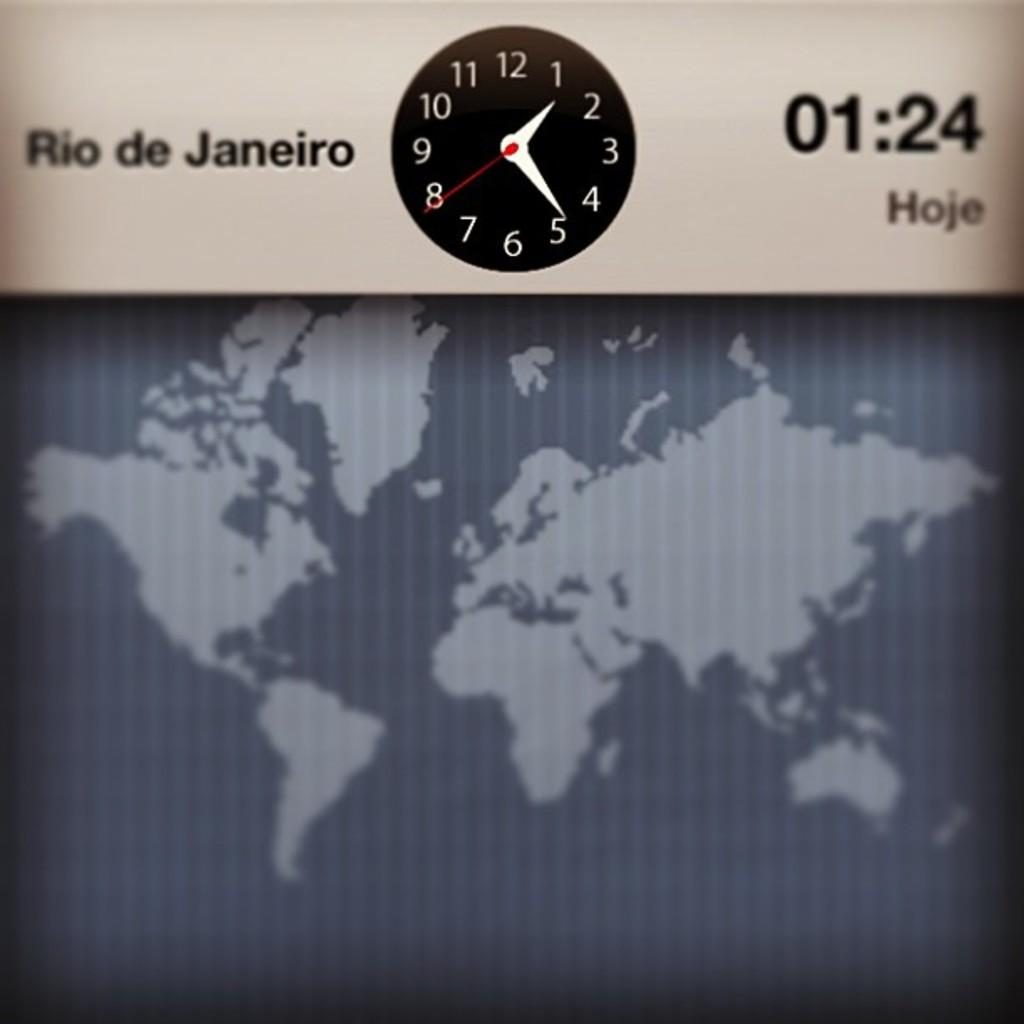<image>
Write a terse but informative summary of the picture. Screen showing a clcok and the name Rio de Janeiro on it. 